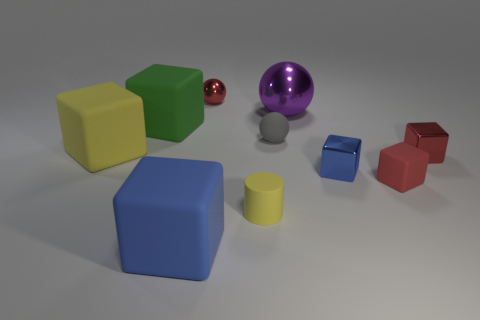Is there a tiny object of the same color as the big shiny ball?
Your answer should be very brief. No. What color is the rubber cube that is in front of the small cylinder?
Offer a very short reply. Blue. There is a tiny red object that is behind the red metal cube; are there any small yellow rubber things that are to the right of it?
Keep it short and to the point. Yes. There is a matte cylinder; does it have the same color as the metal thing that is on the left side of the tiny cylinder?
Ensure brevity in your answer.  No. Are there any large yellow things that have the same material as the large blue cube?
Offer a very short reply. Yes. How many large shiny objects are there?
Provide a short and direct response. 1. There is a sphere behind the big object right of the big blue rubber cube; what is it made of?
Offer a terse response. Metal. There is a cylinder that is the same material as the tiny gray object; what color is it?
Your answer should be very brief. Yellow. There is a large matte thing that is the same color as the cylinder; what shape is it?
Your response must be concise. Cube. There is a rubber block that is on the right side of the big blue block; is it the same size as the blue cube behind the large blue rubber object?
Your answer should be very brief. Yes. 